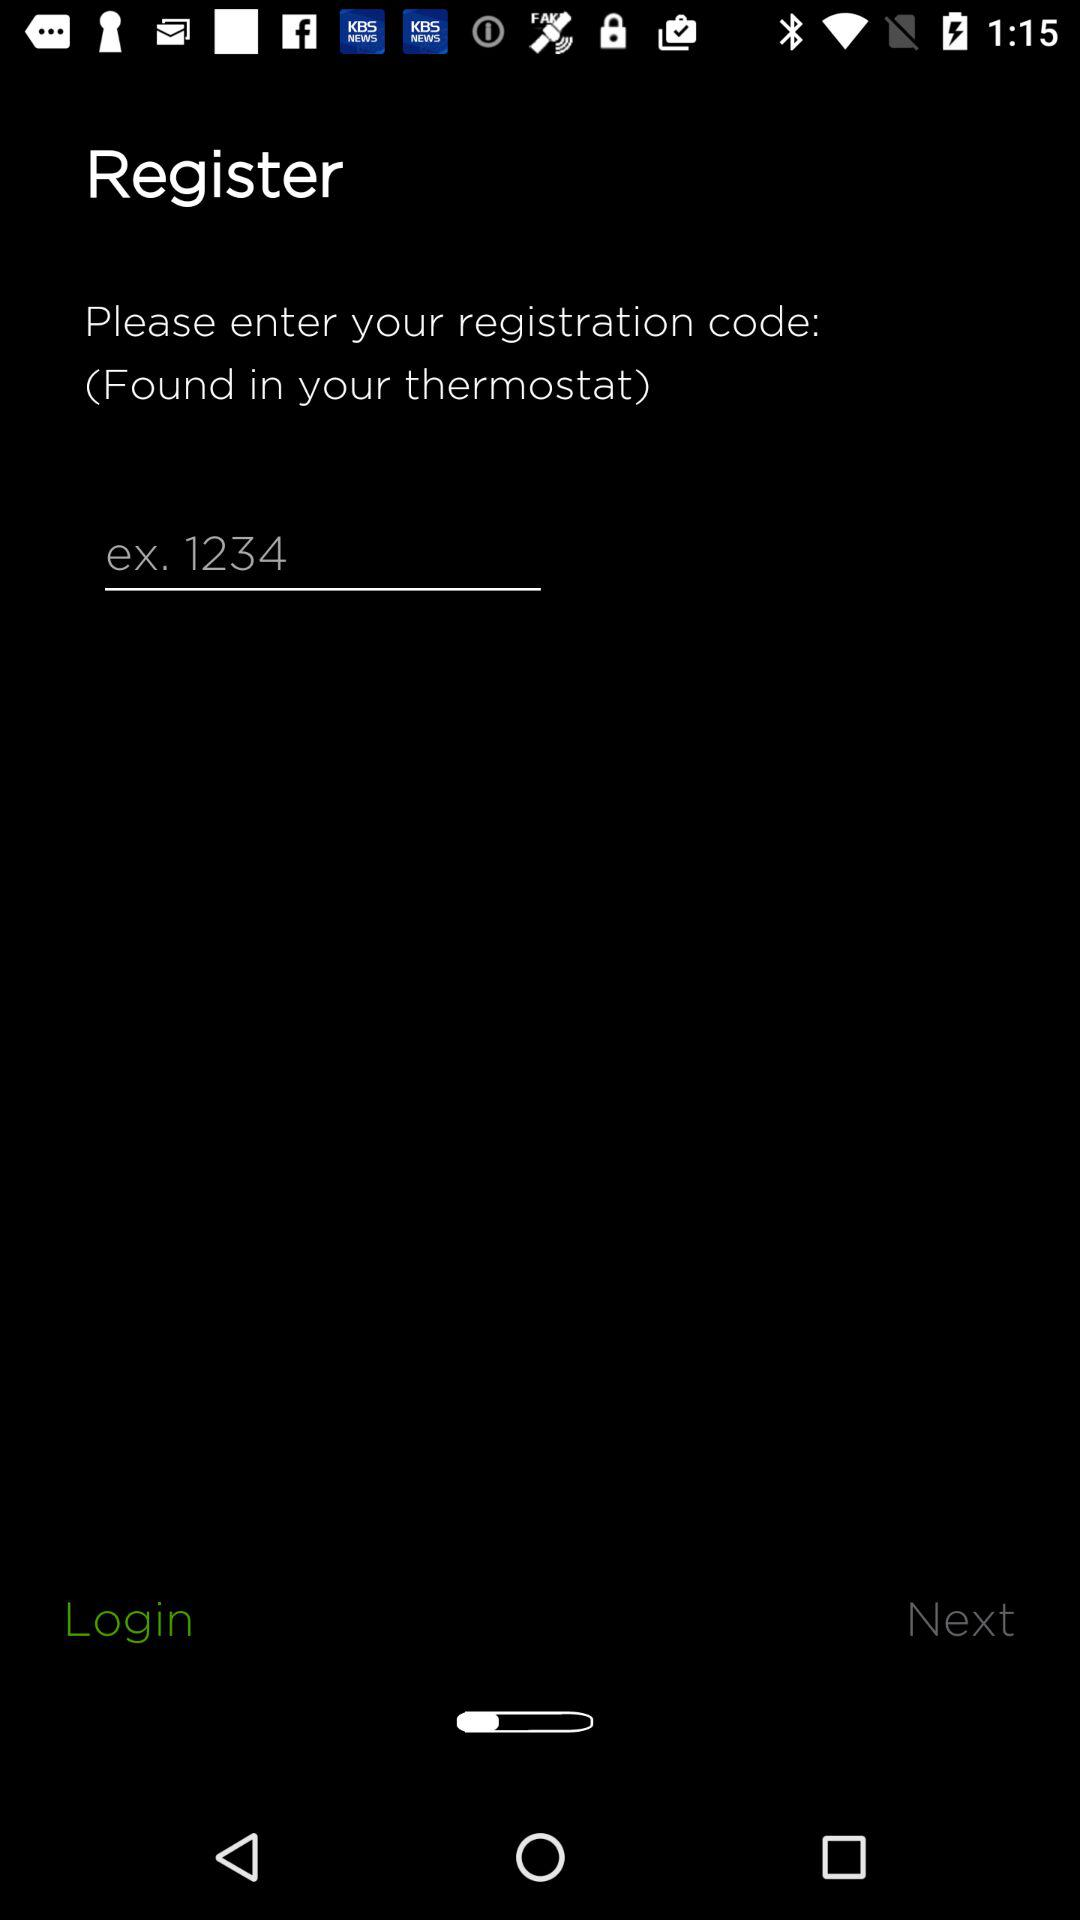What is the number given as an example? The number is 1234. 